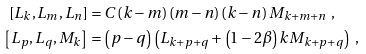<formula> <loc_0><loc_0><loc_500><loc_500>\left [ L _ { k } , L _ { m } , L _ { n } \right ] & = C \left ( k - m \right ) \left ( m - n \right ) \left ( k - n \right ) M _ { k + m + n } \ , \\ \left [ L _ { p } , L _ { q } , M _ { k } \right ] & = \left ( p - q \right ) \left ( L _ { k + p + q } + \left ( 1 - 2 \beta \right ) k M _ { k + p + q } \right ) \ ,</formula> 